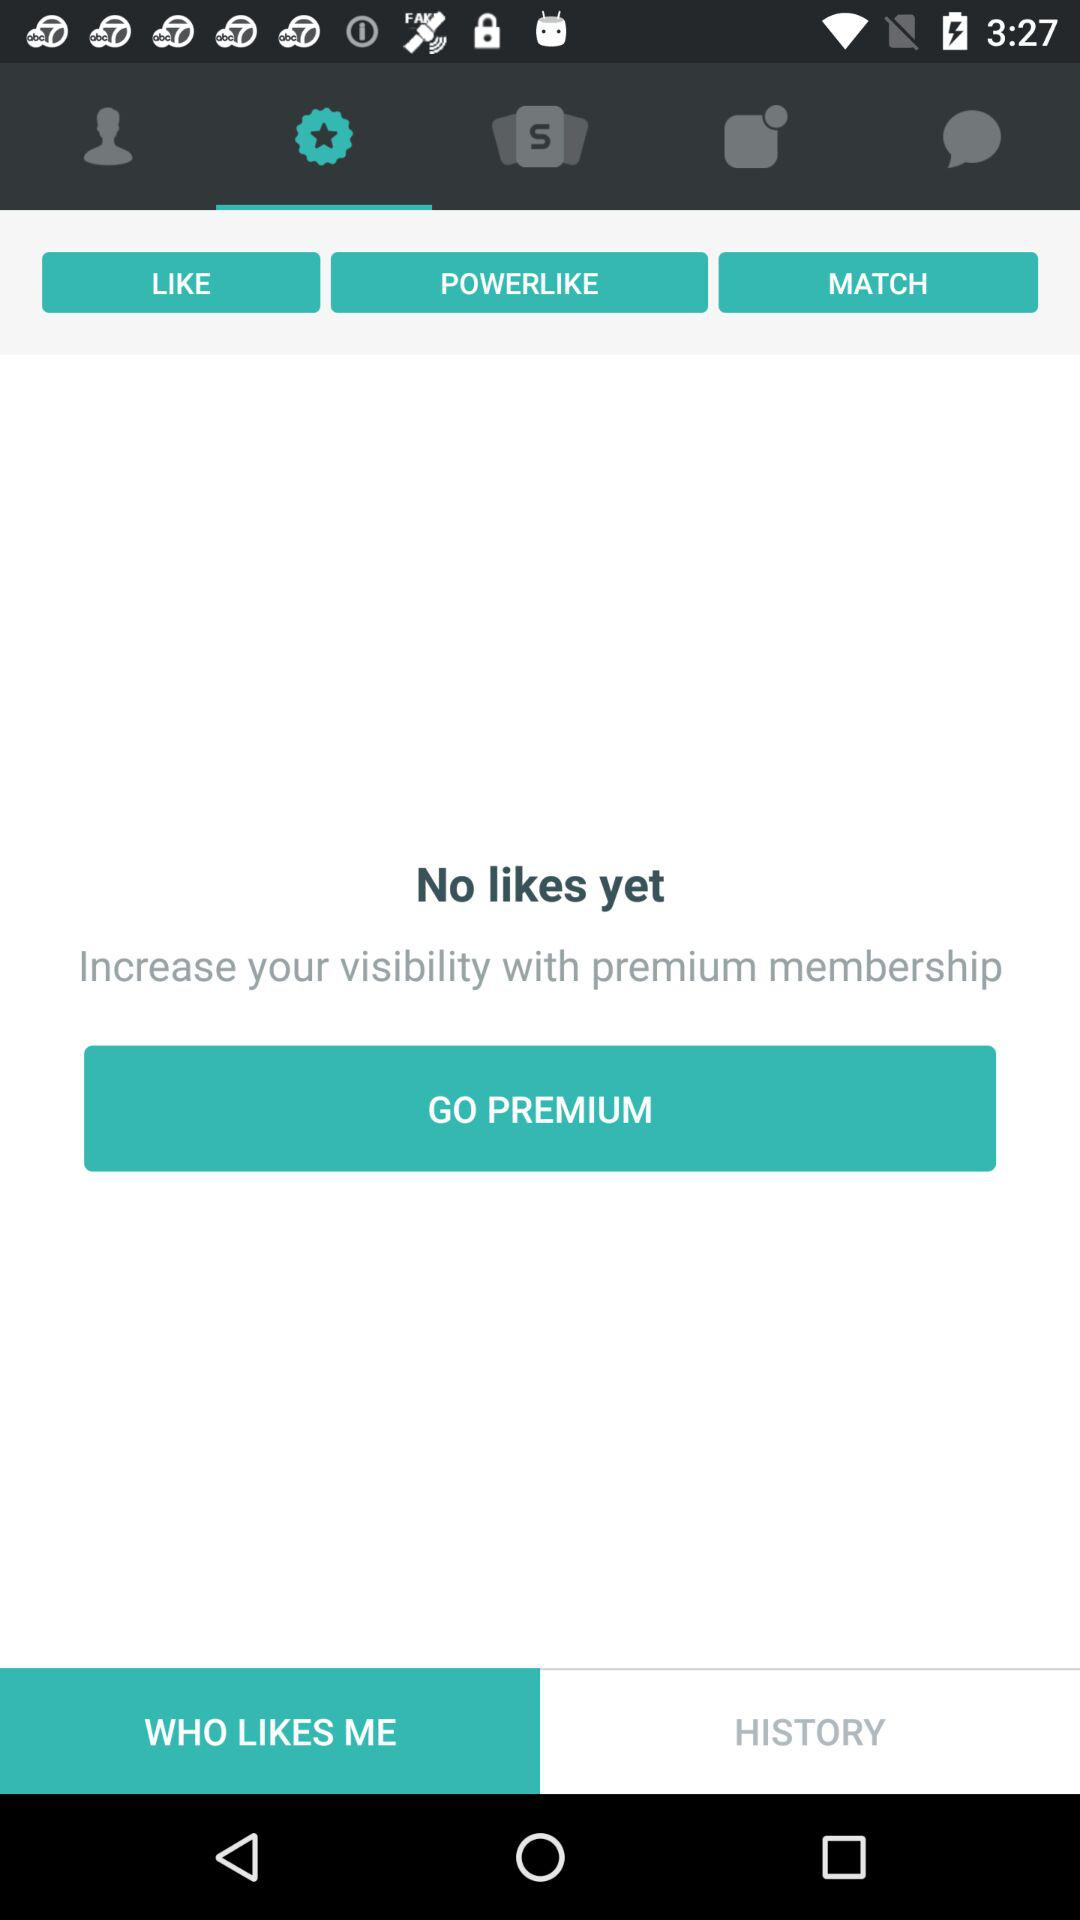Which tab is currently selected? The currently selected tabs are "like" and "WHO LIKES ME". 